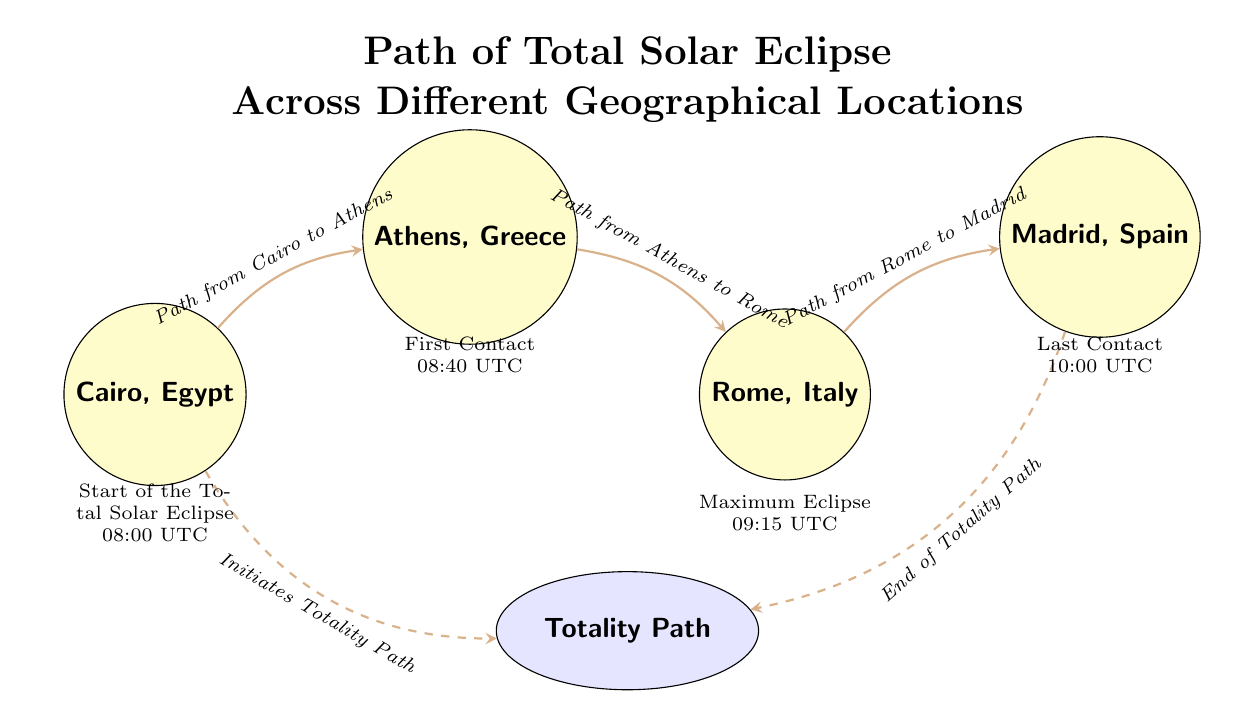What is the first geographical location mentioned in the path? The diagram starts with Cairo, which is the first location listed.
Answer: Cairo, Egypt What time does the total solar eclipse start in Cairo? According to the time label below Cairo, the total solar eclipse starts at 08:00 UTC.
Answer: 08:00 UTC What location experiences the maximum eclipse? The diagram indicates Rome as the location where the maximum eclipse occurs, as noted in the label below the Rome node.
Answer: Rome, Italy How many locations are included in the total solar eclipse path? The diagram lists four distinct locations: Cairo, Athens, Rome, and Madrid, thus the total is four.
Answer: 4 What is the last contact time for the total solar eclipse? The time label below Madrid shows that the last contact occurs at 10:00 UTC.
Answer: 10:00 UTC What kind of path connects Cairo to Athens? The diagram uses a bent edge labeled as "Path from Cairo to Athens," indicating a direct relationship between these two locations.
Answer: Path from Cairo to Athens Which location initiates the totality path? The labeled edge from Cairo to the totality path indicates that Cairo initiates the totality path.
Answer: Cairo What is the path's endpoint according to the diagram? The diagram specifies that the path ends at Madrid, as indicated by the dashed edge leading to the totality path.
Answer: Madrid At what time does the first contact occur in Athens? The time label under the Athens location indicates that the first contact occurs at 08:40 UTC.
Answer: 08:40 UTC 